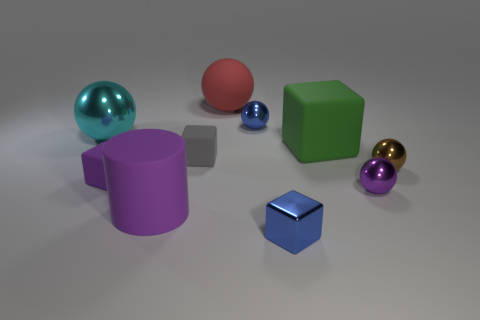Which object seems to be the most reflective, and why? The most reflective object is the large teal sphere to the left. Its glossy surface acts almost like a mirror, reflecting the environment and the light source. Its reflectivity is attributed to its smooth surface finish and material properties, which are characteristic of shiny or metallic objects. 